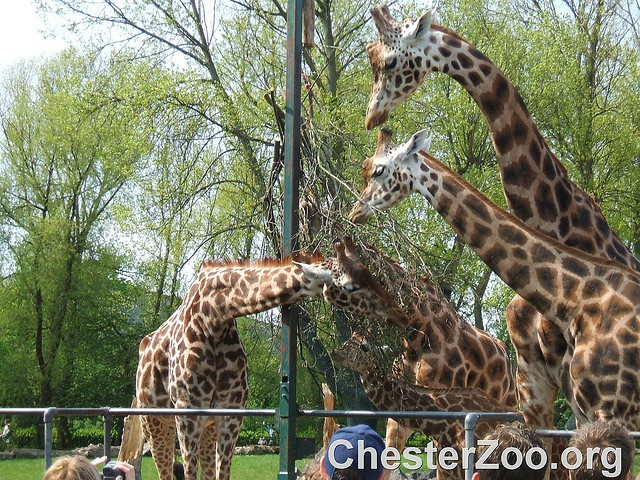Describe the objects in this image and their specific colors. I can see giraffe in white, black, and gray tones, giraffe in white, gray, maroon, and black tones, giraffe in white, gray, black, ivory, and maroon tones, giraffe in white, black, maroon, and gray tones, and giraffe in white, black, and gray tones in this image. 